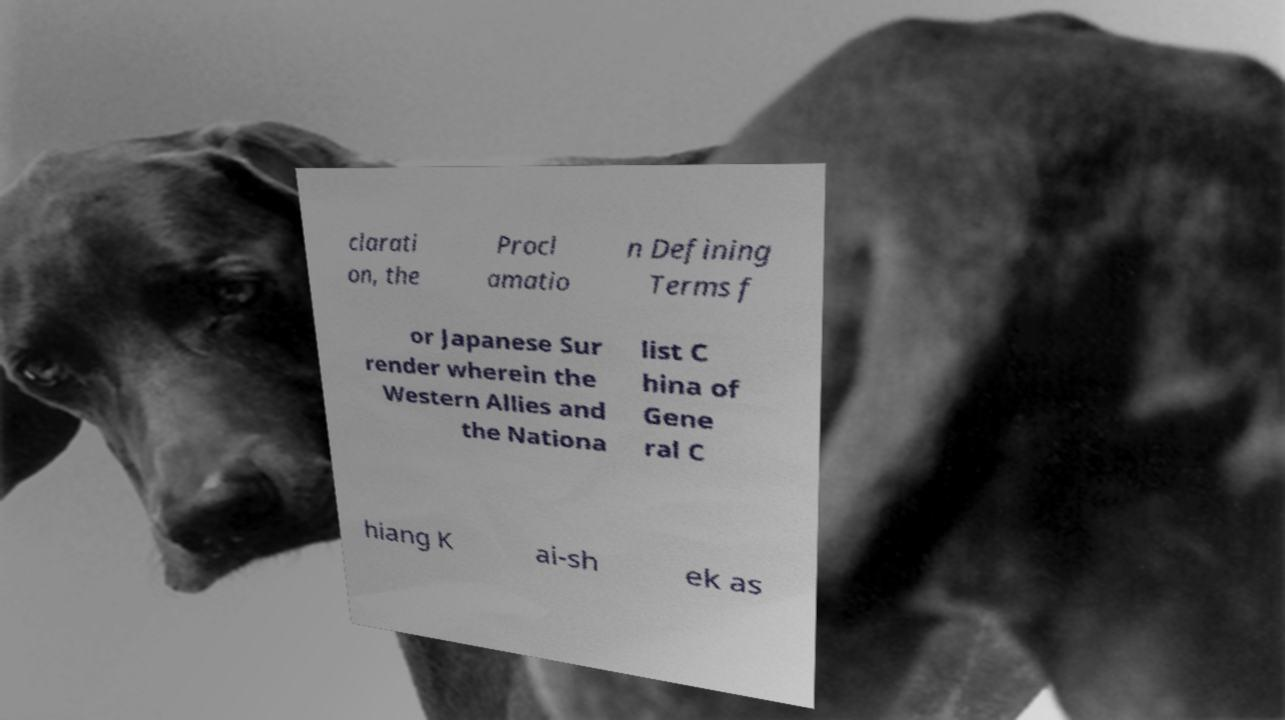Can you read and provide the text displayed in the image?This photo seems to have some interesting text. Can you extract and type it out for me? clarati on, the Procl amatio n Defining Terms f or Japanese Sur render wherein the Western Allies and the Nationa list C hina of Gene ral C hiang K ai-sh ek as 